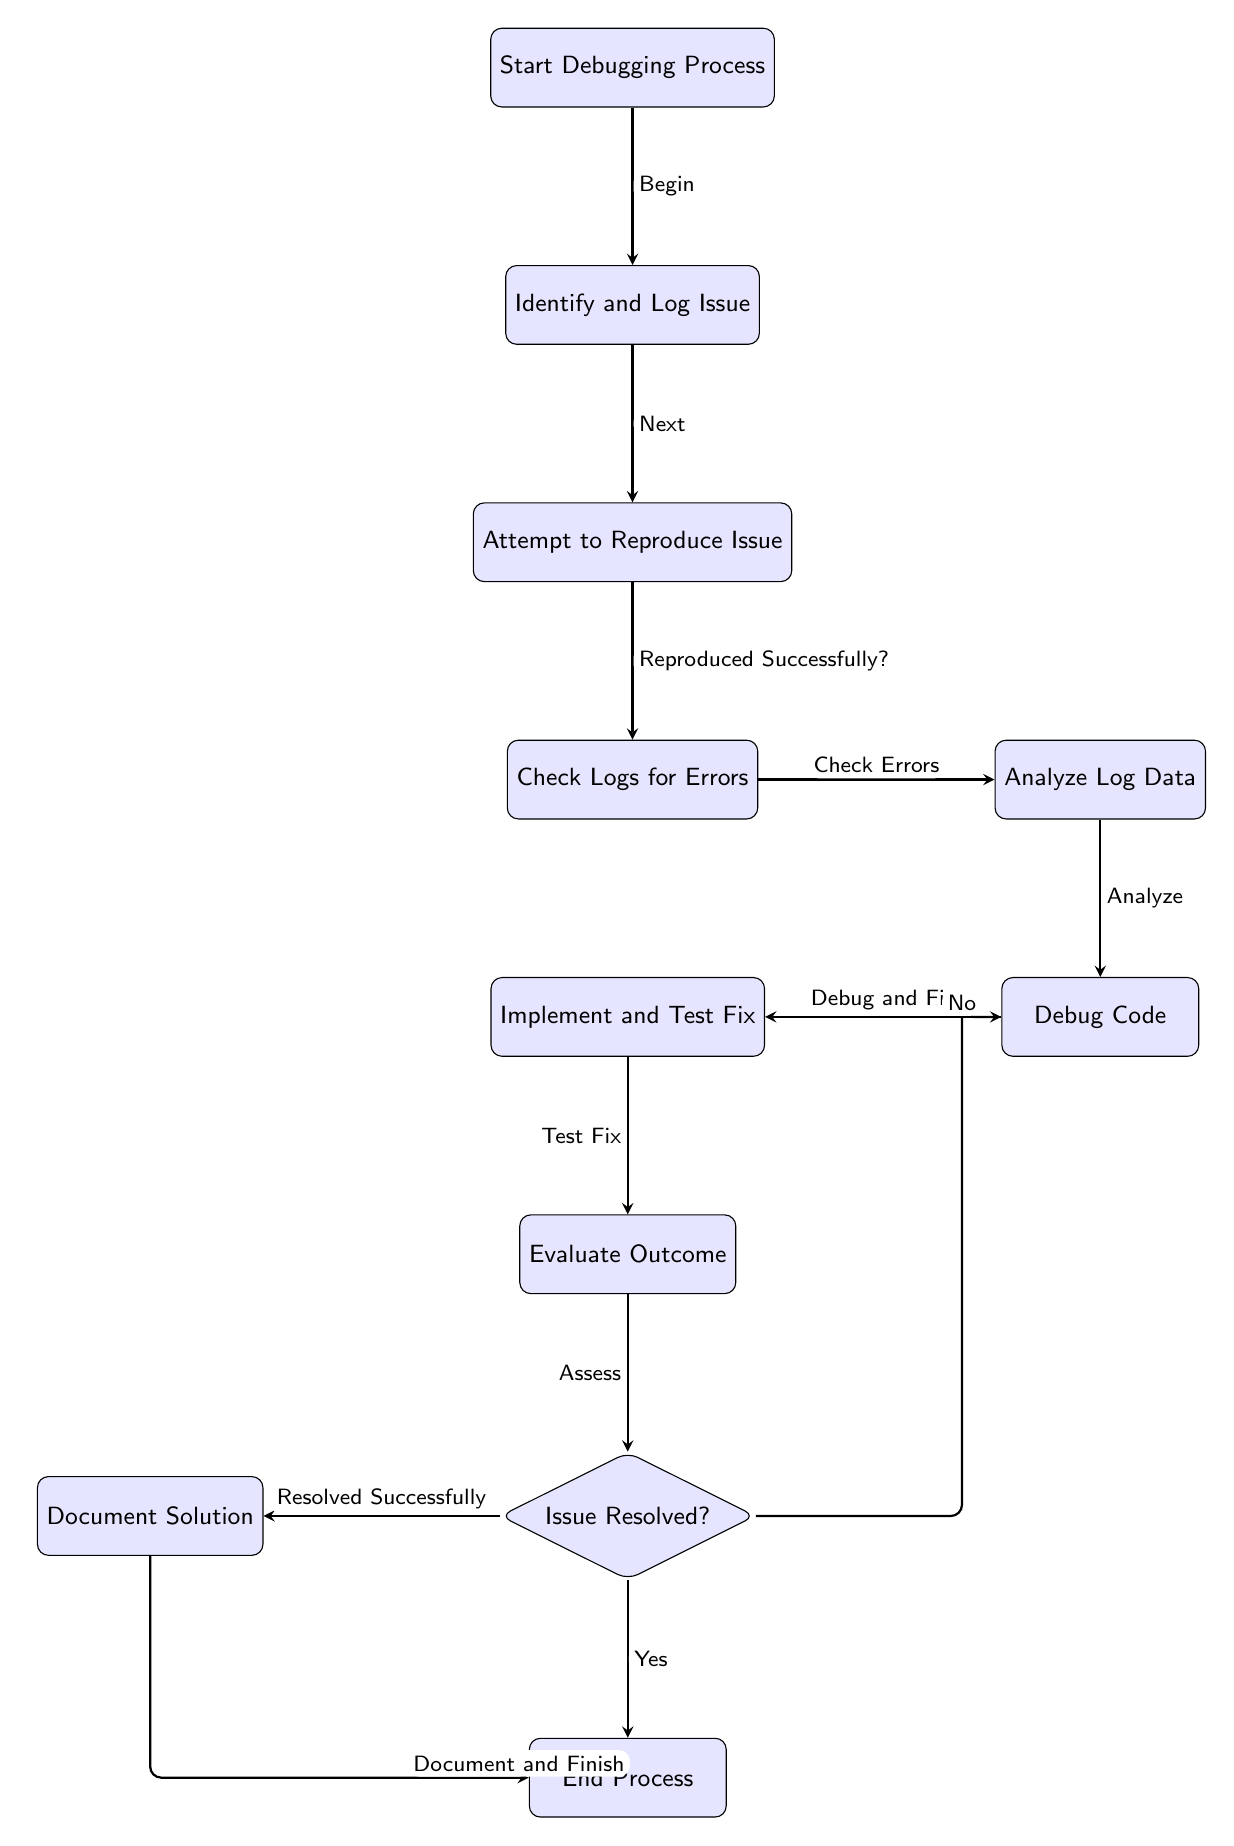What is the first step in the debugging process? The first node in the diagram is labeled "Start Debugging Process," which indicates the initial step of the process.
Answer: Start Debugging Process How many nodes are in the diagram? To determine the number of nodes, we can count each node listed in the diagram. There are a total of 11 nodes present.
Answer: 11 What do you do after logging the issue? Following the "Identify and Log Issue" node, the next step in the diagram is "Attempt to Reproduce Issue."
Answer: Attempt to Reproduce Issue What is the relationship between 'check logs' and 'analyze logs'? The edge connecting "Check Logs for Errors" and "Analyze Log Data" indicates that after checking the logs, the next step is to analyze the log data.
Answer: Check Errors If the issue is not resolved after evaluating the outcome, what is the next step? If the outcome is assessed and found not resolved, the diagram directs back to the "Debug Code" step for further debugging.
Answer: Debug Code How do you finalize the debugging process? To finalize the process, after resolving the issue, you will "Document Solution" and then proceed to the "End Process."
Answer: Document Solution What process follows after testing the fix? The next step after "Implement and Test Fix" is "Evaluate Outcome," where the results of the implementation are assessed.
Answer: Evaluate Outcome Is 'Document Solution' a decision point? No, "Document Solution" is a regular process node that comes after successfully resolving the issue, not a decision point.
Answer: No What happens if you cannot reproduce the issue? The diagram follows a decision path, and if the issue cannot be reproduced, you remain in the "Attempt to Reproduce Issue" phase, attempting again.
Answer: Attempt to Reproduce Issue 